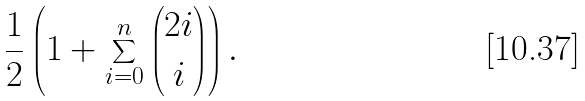<formula> <loc_0><loc_0><loc_500><loc_500>\frac { 1 } { 2 } \left ( 1 + \sum _ { i = 0 } ^ { n } \binom { 2 i } { i } \right ) .</formula> 